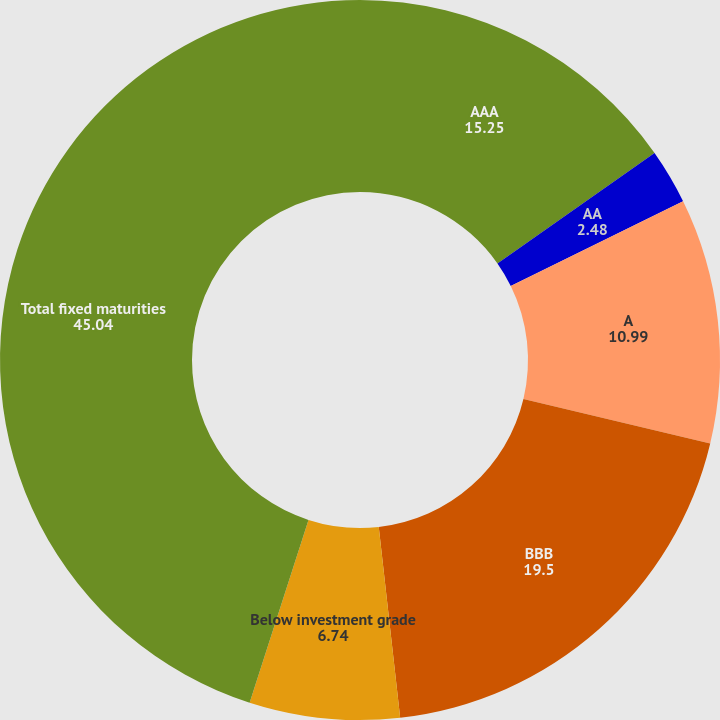<chart> <loc_0><loc_0><loc_500><loc_500><pie_chart><fcel>AAA<fcel>AA<fcel>A<fcel>BBB<fcel>Below investment grade<fcel>Total fixed maturities<nl><fcel>15.25%<fcel>2.48%<fcel>10.99%<fcel>19.5%<fcel>6.74%<fcel>45.04%<nl></chart> 